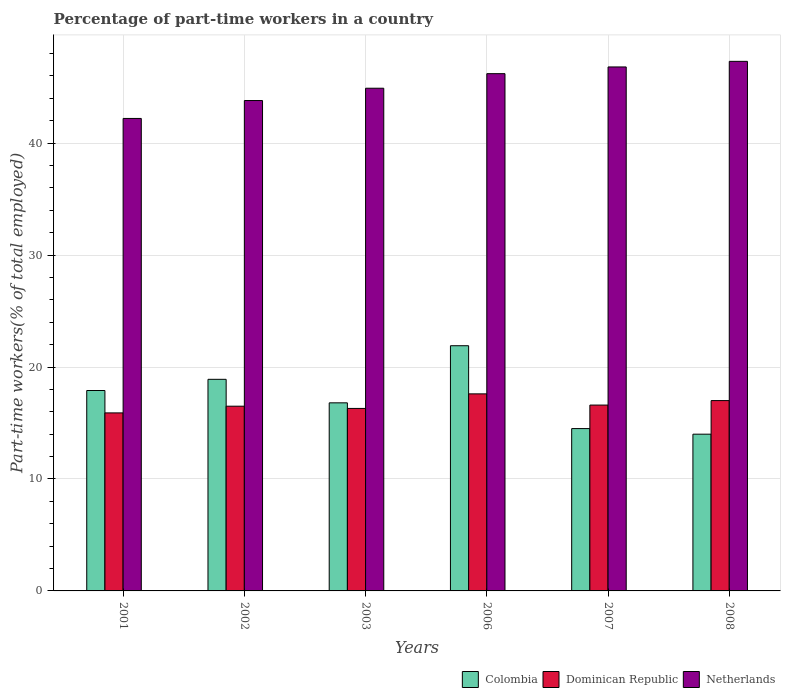How many groups of bars are there?
Provide a succinct answer. 6. Are the number of bars on each tick of the X-axis equal?
Your response must be concise. Yes. How many bars are there on the 3rd tick from the right?
Ensure brevity in your answer.  3. What is the label of the 1st group of bars from the left?
Offer a very short reply. 2001. What is the percentage of part-time workers in Colombia in 2007?
Offer a terse response. 14.5. Across all years, what is the maximum percentage of part-time workers in Colombia?
Give a very brief answer. 21.9. Across all years, what is the minimum percentage of part-time workers in Netherlands?
Your response must be concise. 42.2. In which year was the percentage of part-time workers in Netherlands minimum?
Offer a terse response. 2001. What is the total percentage of part-time workers in Dominican Republic in the graph?
Ensure brevity in your answer.  99.9. What is the difference between the percentage of part-time workers in Dominican Republic in 2007 and that in 2008?
Ensure brevity in your answer.  -0.4. What is the difference between the percentage of part-time workers in Netherlands in 2008 and the percentage of part-time workers in Colombia in 2006?
Give a very brief answer. 25.4. What is the average percentage of part-time workers in Netherlands per year?
Offer a very short reply. 45.2. In the year 2007, what is the difference between the percentage of part-time workers in Netherlands and percentage of part-time workers in Dominican Republic?
Give a very brief answer. 30.2. What is the ratio of the percentage of part-time workers in Colombia in 2003 to that in 2006?
Offer a terse response. 0.77. Is the difference between the percentage of part-time workers in Netherlands in 2002 and 2006 greater than the difference between the percentage of part-time workers in Dominican Republic in 2002 and 2006?
Offer a terse response. No. What is the difference between the highest and the second highest percentage of part-time workers in Dominican Republic?
Ensure brevity in your answer.  0.6. What is the difference between the highest and the lowest percentage of part-time workers in Colombia?
Provide a short and direct response. 7.9. What does the 2nd bar from the left in 2002 represents?
Make the answer very short. Dominican Republic. Are the values on the major ticks of Y-axis written in scientific E-notation?
Keep it short and to the point. No. Does the graph contain grids?
Ensure brevity in your answer.  Yes. What is the title of the graph?
Make the answer very short. Percentage of part-time workers in a country. What is the label or title of the X-axis?
Your answer should be very brief. Years. What is the label or title of the Y-axis?
Your answer should be very brief. Part-time workers(% of total employed). What is the Part-time workers(% of total employed) of Colombia in 2001?
Give a very brief answer. 17.9. What is the Part-time workers(% of total employed) of Dominican Republic in 2001?
Keep it short and to the point. 15.9. What is the Part-time workers(% of total employed) in Netherlands in 2001?
Your response must be concise. 42.2. What is the Part-time workers(% of total employed) of Colombia in 2002?
Give a very brief answer. 18.9. What is the Part-time workers(% of total employed) of Netherlands in 2002?
Keep it short and to the point. 43.8. What is the Part-time workers(% of total employed) of Colombia in 2003?
Offer a very short reply. 16.8. What is the Part-time workers(% of total employed) in Dominican Republic in 2003?
Provide a short and direct response. 16.3. What is the Part-time workers(% of total employed) in Netherlands in 2003?
Give a very brief answer. 44.9. What is the Part-time workers(% of total employed) of Colombia in 2006?
Provide a short and direct response. 21.9. What is the Part-time workers(% of total employed) of Dominican Republic in 2006?
Your answer should be compact. 17.6. What is the Part-time workers(% of total employed) in Netherlands in 2006?
Offer a very short reply. 46.2. What is the Part-time workers(% of total employed) of Dominican Republic in 2007?
Offer a terse response. 16.6. What is the Part-time workers(% of total employed) of Netherlands in 2007?
Provide a succinct answer. 46.8. What is the Part-time workers(% of total employed) in Dominican Republic in 2008?
Your answer should be compact. 17. What is the Part-time workers(% of total employed) of Netherlands in 2008?
Offer a very short reply. 47.3. Across all years, what is the maximum Part-time workers(% of total employed) of Colombia?
Make the answer very short. 21.9. Across all years, what is the maximum Part-time workers(% of total employed) of Dominican Republic?
Offer a very short reply. 17.6. Across all years, what is the maximum Part-time workers(% of total employed) in Netherlands?
Ensure brevity in your answer.  47.3. Across all years, what is the minimum Part-time workers(% of total employed) in Colombia?
Ensure brevity in your answer.  14. Across all years, what is the minimum Part-time workers(% of total employed) of Dominican Republic?
Offer a terse response. 15.9. Across all years, what is the minimum Part-time workers(% of total employed) of Netherlands?
Your response must be concise. 42.2. What is the total Part-time workers(% of total employed) in Colombia in the graph?
Keep it short and to the point. 104. What is the total Part-time workers(% of total employed) in Dominican Republic in the graph?
Your answer should be very brief. 99.9. What is the total Part-time workers(% of total employed) of Netherlands in the graph?
Provide a succinct answer. 271.2. What is the difference between the Part-time workers(% of total employed) of Dominican Republic in 2001 and that in 2002?
Provide a succinct answer. -0.6. What is the difference between the Part-time workers(% of total employed) of Netherlands in 2001 and that in 2002?
Provide a succinct answer. -1.6. What is the difference between the Part-time workers(% of total employed) in Netherlands in 2001 and that in 2003?
Make the answer very short. -2.7. What is the difference between the Part-time workers(% of total employed) of Dominican Republic in 2001 and that in 2006?
Keep it short and to the point. -1.7. What is the difference between the Part-time workers(% of total employed) of Dominican Republic in 2001 and that in 2007?
Your answer should be very brief. -0.7. What is the difference between the Part-time workers(% of total employed) of Colombia in 2001 and that in 2008?
Give a very brief answer. 3.9. What is the difference between the Part-time workers(% of total employed) of Dominican Republic in 2002 and that in 2003?
Provide a succinct answer. 0.2. What is the difference between the Part-time workers(% of total employed) of Netherlands in 2002 and that in 2006?
Provide a short and direct response. -2.4. What is the difference between the Part-time workers(% of total employed) in Dominican Republic in 2002 and that in 2007?
Your response must be concise. -0.1. What is the difference between the Part-time workers(% of total employed) in Dominican Republic in 2002 and that in 2008?
Offer a terse response. -0.5. What is the difference between the Part-time workers(% of total employed) in Netherlands in 2002 and that in 2008?
Provide a short and direct response. -3.5. What is the difference between the Part-time workers(% of total employed) in Colombia in 2003 and that in 2006?
Your response must be concise. -5.1. What is the difference between the Part-time workers(% of total employed) of Netherlands in 2003 and that in 2006?
Give a very brief answer. -1.3. What is the difference between the Part-time workers(% of total employed) in Dominican Republic in 2003 and that in 2007?
Your response must be concise. -0.3. What is the difference between the Part-time workers(% of total employed) in Colombia in 2003 and that in 2008?
Provide a succinct answer. 2.8. What is the difference between the Part-time workers(% of total employed) of Dominican Republic in 2003 and that in 2008?
Make the answer very short. -0.7. What is the difference between the Part-time workers(% of total employed) in Colombia in 2006 and that in 2007?
Offer a terse response. 7.4. What is the difference between the Part-time workers(% of total employed) of Dominican Republic in 2006 and that in 2007?
Offer a very short reply. 1. What is the difference between the Part-time workers(% of total employed) of Dominican Republic in 2006 and that in 2008?
Give a very brief answer. 0.6. What is the difference between the Part-time workers(% of total employed) in Netherlands in 2006 and that in 2008?
Offer a terse response. -1.1. What is the difference between the Part-time workers(% of total employed) in Colombia in 2007 and that in 2008?
Provide a succinct answer. 0.5. What is the difference between the Part-time workers(% of total employed) of Dominican Republic in 2007 and that in 2008?
Ensure brevity in your answer.  -0.4. What is the difference between the Part-time workers(% of total employed) in Netherlands in 2007 and that in 2008?
Your response must be concise. -0.5. What is the difference between the Part-time workers(% of total employed) of Colombia in 2001 and the Part-time workers(% of total employed) of Netherlands in 2002?
Your response must be concise. -25.9. What is the difference between the Part-time workers(% of total employed) of Dominican Republic in 2001 and the Part-time workers(% of total employed) of Netherlands in 2002?
Provide a succinct answer. -27.9. What is the difference between the Part-time workers(% of total employed) in Dominican Republic in 2001 and the Part-time workers(% of total employed) in Netherlands in 2003?
Give a very brief answer. -29. What is the difference between the Part-time workers(% of total employed) of Colombia in 2001 and the Part-time workers(% of total employed) of Dominican Republic in 2006?
Your answer should be very brief. 0.3. What is the difference between the Part-time workers(% of total employed) of Colombia in 2001 and the Part-time workers(% of total employed) of Netherlands in 2006?
Keep it short and to the point. -28.3. What is the difference between the Part-time workers(% of total employed) of Dominican Republic in 2001 and the Part-time workers(% of total employed) of Netherlands in 2006?
Your response must be concise. -30.3. What is the difference between the Part-time workers(% of total employed) in Colombia in 2001 and the Part-time workers(% of total employed) in Netherlands in 2007?
Give a very brief answer. -28.9. What is the difference between the Part-time workers(% of total employed) in Dominican Republic in 2001 and the Part-time workers(% of total employed) in Netherlands in 2007?
Offer a terse response. -30.9. What is the difference between the Part-time workers(% of total employed) in Colombia in 2001 and the Part-time workers(% of total employed) in Netherlands in 2008?
Provide a succinct answer. -29.4. What is the difference between the Part-time workers(% of total employed) in Dominican Republic in 2001 and the Part-time workers(% of total employed) in Netherlands in 2008?
Give a very brief answer. -31.4. What is the difference between the Part-time workers(% of total employed) in Colombia in 2002 and the Part-time workers(% of total employed) in Dominican Republic in 2003?
Provide a short and direct response. 2.6. What is the difference between the Part-time workers(% of total employed) of Dominican Republic in 2002 and the Part-time workers(% of total employed) of Netherlands in 2003?
Ensure brevity in your answer.  -28.4. What is the difference between the Part-time workers(% of total employed) in Colombia in 2002 and the Part-time workers(% of total employed) in Dominican Republic in 2006?
Keep it short and to the point. 1.3. What is the difference between the Part-time workers(% of total employed) in Colombia in 2002 and the Part-time workers(% of total employed) in Netherlands in 2006?
Offer a terse response. -27.3. What is the difference between the Part-time workers(% of total employed) in Dominican Republic in 2002 and the Part-time workers(% of total employed) in Netherlands in 2006?
Your answer should be compact. -29.7. What is the difference between the Part-time workers(% of total employed) in Colombia in 2002 and the Part-time workers(% of total employed) in Netherlands in 2007?
Offer a terse response. -27.9. What is the difference between the Part-time workers(% of total employed) of Dominican Republic in 2002 and the Part-time workers(% of total employed) of Netherlands in 2007?
Keep it short and to the point. -30.3. What is the difference between the Part-time workers(% of total employed) of Colombia in 2002 and the Part-time workers(% of total employed) of Netherlands in 2008?
Your answer should be very brief. -28.4. What is the difference between the Part-time workers(% of total employed) in Dominican Republic in 2002 and the Part-time workers(% of total employed) in Netherlands in 2008?
Keep it short and to the point. -30.8. What is the difference between the Part-time workers(% of total employed) in Colombia in 2003 and the Part-time workers(% of total employed) in Netherlands in 2006?
Keep it short and to the point. -29.4. What is the difference between the Part-time workers(% of total employed) of Dominican Republic in 2003 and the Part-time workers(% of total employed) of Netherlands in 2006?
Your answer should be compact. -29.9. What is the difference between the Part-time workers(% of total employed) of Colombia in 2003 and the Part-time workers(% of total employed) of Netherlands in 2007?
Offer a terse response. -30. What is the difference between the Part-time workers(% of total employed) in Dominican Republic in 2003 and the Part-time workers(% of total employed) in Netherlands in 2007?
Give a very brief answer. -30.5. What is the difference between the Part-time workers(% of total employed) of Colombia in 2003 and the Part-time workers(% of total employed) of Netherlands in 2008?
Your answer should be very brief. -30.5. What is the difference between the Part-time workers(% of total employed) in Dominican Republic in 2003 and the Part-time workers(% of total employed) in Netherlands in 2008?
Your answer should be very brief. -31. What is the difference between the Part-time workers(% of total employed) in Colombia in 2006 and the Part-time workers(% of total employed) in Netherlands in 2007?
Offer a terse response. -24.9. What is the difference between the Part-time workers(% of total employed) of Dominican Republic in 2006 and the Part-time workers(% of total employed) of Netherlands in 2007?
Provide a short and direct response. -29.2. What is the difference between the Part-time workers(% of total employed) of Colombia in 2006 and the Part-time workers(% of total employed) of Dominican Republic in 2008?
Offer a very short reply. 4.9. What is the difference between the Part-time workers(% of total employed) of Colombia in 2006 and the Part-time workers(% of total employed) of Netherlands in 2008?
Keep it short and to the point. -25.4. What is the difference between the Part-time workers(% of total employed) of Dominican Republic in 2006 and the Part-time workers(% of total employed) of Netherlands in 2008?
Your response must be concise. -29.7. What is the difference between the Part-time workers(% of total employed) of Colombia in 2007 and the Part-time workers(% of total employed) of Dominican Republic in 2008?
Your answer should be very brief. -2.5. What is the difference between the Part-time workers(% of total employed) of Colombia in 2007 and the Part-time workers(% of total employed) of Netherlands in 2008?
Your response must be concise. -32.8. What is the difference between the Part-time workers(% of total employed) in Dominican Republic in 2007 and the Part-time workers(% of total employed) in Netherlands in 2008?
Your response must be concise. -30.7. What is the average Part-time workers(% of total employed) of Colombia per year?
Give a very brief answer. 17.33. What is the average Part-time workers(% of total employed) of Dominican Republic per year?
Keep it short and to the point. 16.65. What is the average Part-time workers(% of total employed) in Netherlands per year?
Provide a succinct answer. 45.2. In the year 2001, what is the difference between the Part-time workers(% of total employed) of Colombia and Part-time workers(% of total employed) of Dominican Republic?
Your answer should be very brief. 2. In the year 2001, what is the difference between the Part-time workers(% of total employed) in Colombia and Part-time workers(% of total employed) in Netherlands?
Your answer should be very brief. -24.3. In the year 2001, what is the difference between the Part-time workers(% of total employed) of Dominican Republic and Part-time workers(% of total employed) of Netherlands?
Give a very brief answer. -26.3. In the year 2002, what is the difference between the Part-time workers(% of total employed) in Colombia and Part-time workers(% of total employed) in Dominican Republic?
Provide a short and direct response. 2.4. In the year 2002, what is the difference between the Part-time workers(% of total employed) of Colombia and Part-time workers(% of total employed) of Netherlands?
Offer a very short reply. -24.9. In the year 2002, what is the difference between the Part-time workers(% of total employed) of Dominican Republic and Part-time workers(% of total employed) of Netherlands?
Offer a very short reply. -27.3. In the year 2003, what is the difference between the Part-time workers(% of total employed) in Colombia and Part-time workers(% of total employed) in Dominican Republic?
Your answer should be very brief. 0.5. In the year 2003, what is the difference between the Part-time workers(% of total employed) of Colombia and Part-time workers(% of total employed) of Netherlands?
Your answer should be compact. -28.1. In the year 2003, what is the difference between the Part-time workers(% of total employed) in Dominican Republic and Part-time workers(% of total employed) in Netherlands?
Provide a short and direct response. -28.6. In the year 2006, what is the difference between the Part-time workers(% of total employed) in Colombia and Part-time workers(% of total employed) in Dominican Republic?
Your answer should be compact. 4.3. In the year 2006, what is the difference between the Part-time workers(% of total employed) of Colombia and Part-time workers(% of total employed) of Netherlands?
Provide a succinct answer. -24.3. In the year 2006, what is the difference between the Part-time workers(% of total employed) in Dominican Republic and Part-time workers(% of total employed) in Netherlands?
Ensure brevity in your answer.  -28.6. In the year 2007, what is the difference between the Part-time workers(% of total employed) in Colombia and Part-time workers(% of total employed) in Netherlands?
Ensure brevity in your answer.  -32.3. In the year 2007, what is the difference between the Part-time workers(% of total employed) of Dominican Republic and Part-time workers(% of total employed) of Netherlands?
Offer a very short reply. -30.2. In the year 2008, what is the difference between the Part-time workers(% of total employed) in Colombia and Part-time workers(% of total employed) in Netherlands?
Provide a short and direct response. -33.3. In the year 2008, what is the difference between the Part-time workers(% of total employed) in Dominican Republic and Part-time workers(% of total employed) in Netherlands?
Your answer should be very brief. -30.3. What is the ratio of the Part-time workers(% of total employed) in Colombia in 2001 to that in 2002?
Ensure brevity in your answer.  0.95. What is the ratio of the Part-time workers(% of total employed) in Dominican Republic in 2001 to that in 2002?
Your answer should be compact. 0.96. What is the ratio of the Part-time workers(% of total employed) in Netherlands in 2001 to that in 2002?
Your answer should be very brief. 0.96. What is the ratio of the Part-time workers(% of total employed) of Colombia in 2001 to that in 2003?
Keep it short and to the point. 1.07. What is the ratio of the Part-time workers(% of total employed) in Dominican Republic in 2001 to that in 2003?
Provide a succinct answer. 0.98. What is the ratio of the Part-time workers(% of total employed) of Netherlands in 2001 to that in 2003?
Keep it short and to the point. 0.94. What is the ratio of the Part-time workers(% of total employed) of Colombia in 2001 to that in 2006?
Keep it short and to the point. 0.82. What is the ratio of the Part-time workers(% of total employed) of Dominican Republic in 2001 to that in 2006?
Your response must be concise. 0.9. What is the ratio of the Part-time workers(% of total employed) in Netherlands in 2001 to that in 2006?
Keep it short and to the point. 0.91. What is the ratio of the Part-time workers(% of total employed) in Colombia in 2001 to that in 2007?
Your answer should be compact. 1.23. What is the ratio of the Part-time workers(% of total employed) in Dominican Republic in 2001 to that in 2007?
Make the answer very short. 0.96. What is the ratio of the Part-time workers(% of total employed) of Netherlands in 2001 to that in 2007?
Offer a very short reply. 0.9. What is the ratio of the Part-time workers(% of total employed) of Colombia in 2001 to that in 2008?
Provide a short and direct response. 1.28. What is the ratio of the Part-time workers(% of total employed) in Dominican Republic in 2001 to that in 2008?
Ensure brevity in your answer.  0.94. What is the ratio of the Part-time workers(% of total employed) in Netherlands in 2001 to that in 2008?
Provide a succinct answer. 0.89. What is the ratio of the Part-time workers(% of total employed) of Colombia in 2002 to that in 2003?
Offer a very short reply. 1.12. What is the ratio of the Part-time workers(% of total employed) of Dominican Republic in 2002 to that in 2003?
Give a very brief answer. 1.01. What is the ratio of the Part-time workers(% of total employed) of Netherlands in 2002 to that in 2003?
Keep it short and to the point. 0.98. What is the ratio of the Part-time workers(% of total employed) in Colombia in 2002 to that in 2006?
Your response must be concise. 0.86. What is the ratio of the Part-time workers(% of total employed) of Netherlands in 2002 to that in 2006?
Your response must be concise. 0.95. What is the ratio of the Part-time workers(% of total employed) in Colombia in 2002 to that in 2007?
Provide a succinct answer. 1.3. What is the ratio of the Part-time workers(% of total employed) in Dominican Republic in 2002 to that in 2007?
Ensure brevity in your answer.  0.99. What is the ratio of the Part-time workers(% of total employed) of Netherlands in 2002 to that in 2007?
Your response must be concise. 0.94. What is the ratio of the Part-time workers(% of total employed) in Colombia in 2002 to that in 2008?
Provide a short and direct response. 1.35. What is the ratio of the Part-time workers(% of total employed) of Dominican Republic in 2002 to that in 2008?
Keep it short and to the point. 0.97. What is the ratio of the Part-time workers(% of total employed) in Netherlands in 2002 to that in 2008?
Provide a succinct answer. 0.93. What is the ratio of the Part-time workers(% of total employed) of Colombia in 2003 to that in 2006?
Offer a very short reply. 0.77. What is the ratio of the Part-time workers(% of total employed) of Dominican Republic in 2003 to that in 2006?
Offer a very short reply. 0.93. What is the ratio of the Part-time workers(% of total employed) in Netherlands in 2003 to that in 2006?
Keep it short and to the point. 0.97. What is the ratio of the Part-time workers(% of total employed) in Colombia in 2003 to that in 2007?
Your answer should be very brief. 1.16. What is the ratio of the Part-time workers(% of total employed) in Dominican Republic in 2003 to that in 2007?
Keep it short and to the point. 0.98. What is the ratio of the Part-time workers(% of total employed) in Netherlands in 2003 to that in 2007?
Ensure brevity in your answer.  0.96. What is the ratio of the Part-time workers(% of total employed) of Dominican Republic in 2003 to that in 2008?
Provide a succinct answer. 0.96. What is the ratio of the Part-time workers(% of total employed) of Netherlands in 2003 to that in 2008?
Your answer should be very brief. 0.95. What is the ratio of the Part-time workers(% of total employed) in Colombia in 2006 to that in 2007?
Provide a succinct answer. 1.51. What is the ratio of the Part-time workers(% of total employed) in Dominican Republic in 2006 to that in 2007?
Your response must be concise. 1.06. What is the ratio of the Part-time workers(% of total employed) of Netherlands in 2006 to that in 2007?
Offer a terse response. 0.99. What is the ratio of the Part-time workers(% of total employed) of Colombia in 2006 to that in 2008?
Offer a terse response. 1.56. What is the ratio of the Part-time workers(% of total employed) of Dominican Republic in 2006 to that in 2008?
Ensure brevity in your answer.  1.04. What is the ratio of the Part-time workers(% of total employed) in Netherlands in 2006 to that in 2008?
Keep it short and to the point. 0.98. What is the ratio of the Part-time workers(% of total employed) of Colombia in 2007 to that in 2008?
Make the answer very short. 1.04. What is the ratio of the Part-time workers(% of total employed) in Dominican Republic in 2007 to that in 2008?
Provide a short and direct response. 0.98. What is the difference between the highest and the second highest Part-time workers(% of total employed) in Dominican Republic?
Offer a terse response. 0.6. What is the difference between the highest and the lowest Part-time workers(% of total employed) of Colombia?
Your answer should be compact. 7.9. What is the difference between the highest and the lowest Part-time workers(% of total employed) of Dominican Republic?
Provide a succinct answer. 1.7. What is the difference between the highest and the lowest Part-time workers(% of total employed) in Netherlands?
Ensure brevity in your answer.  5.1. 